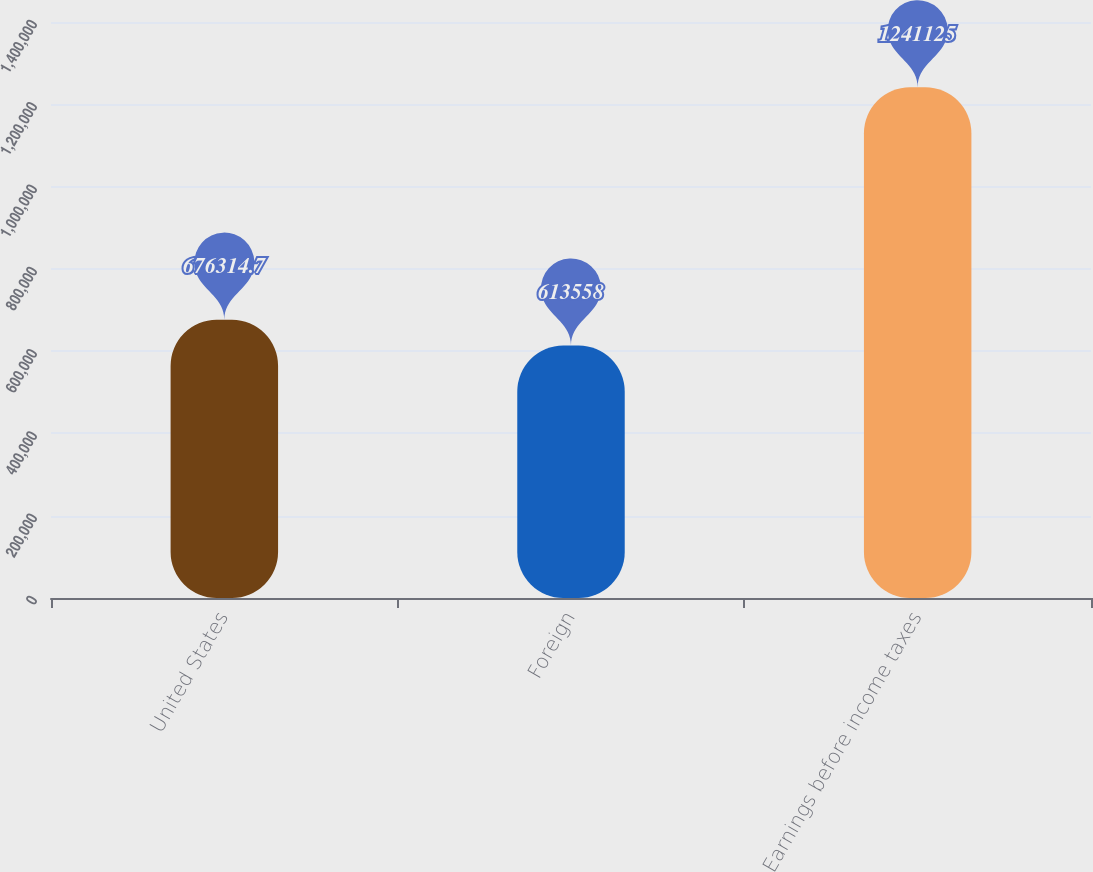Convert chart to OTSL. <chart><loc_0><loc_0><loc_500><loc_500><bar_chart><fcel>United States<fcel>Foreign<fcel>Earnings before income taxes<nl><fcel>676315<fcel>613558<fcel>1.24112e+06<nl></chart> 